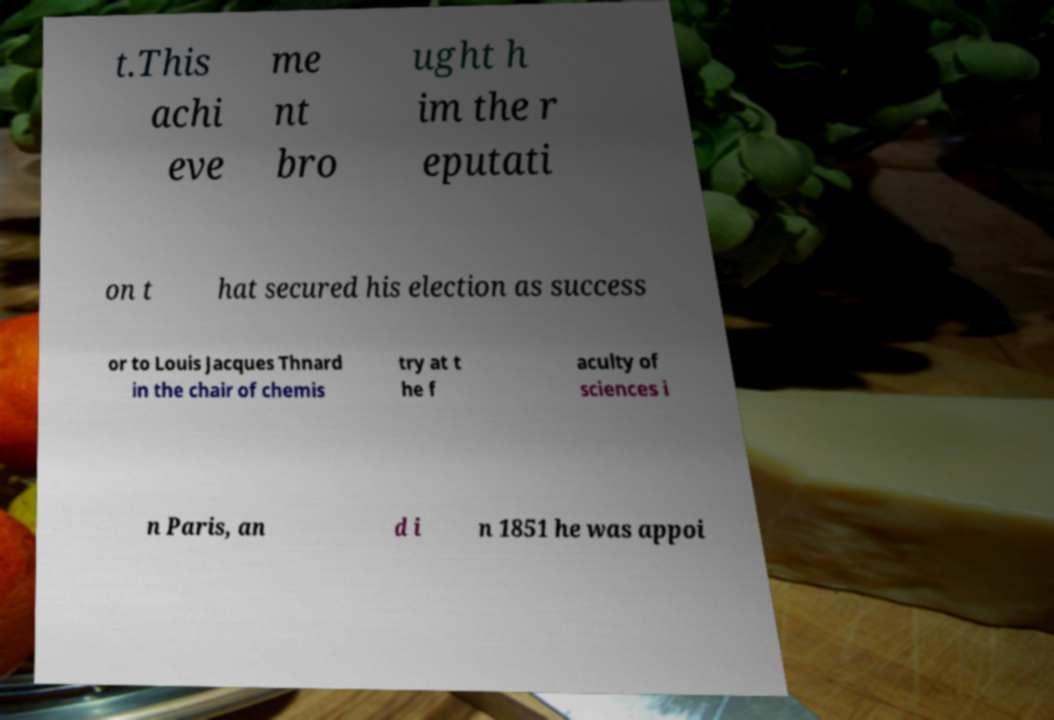Can you accurately transcribe the text from the provided image for me? t.This achi eve me nt bro ught h im the r eputati on t hat secured his election as success or to Louis Jacques Thnard in the chair of chemis try at t he f aculty of sciences i n Paris, an d i n 1851 he was appoi 